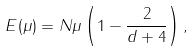<formula> <loc_0><loc_0><loc_500><loc_500>E ( \mu ) = N \mu \left ( 1 - \frac { 2 } { d + 4 } \right ) ,</formula> 